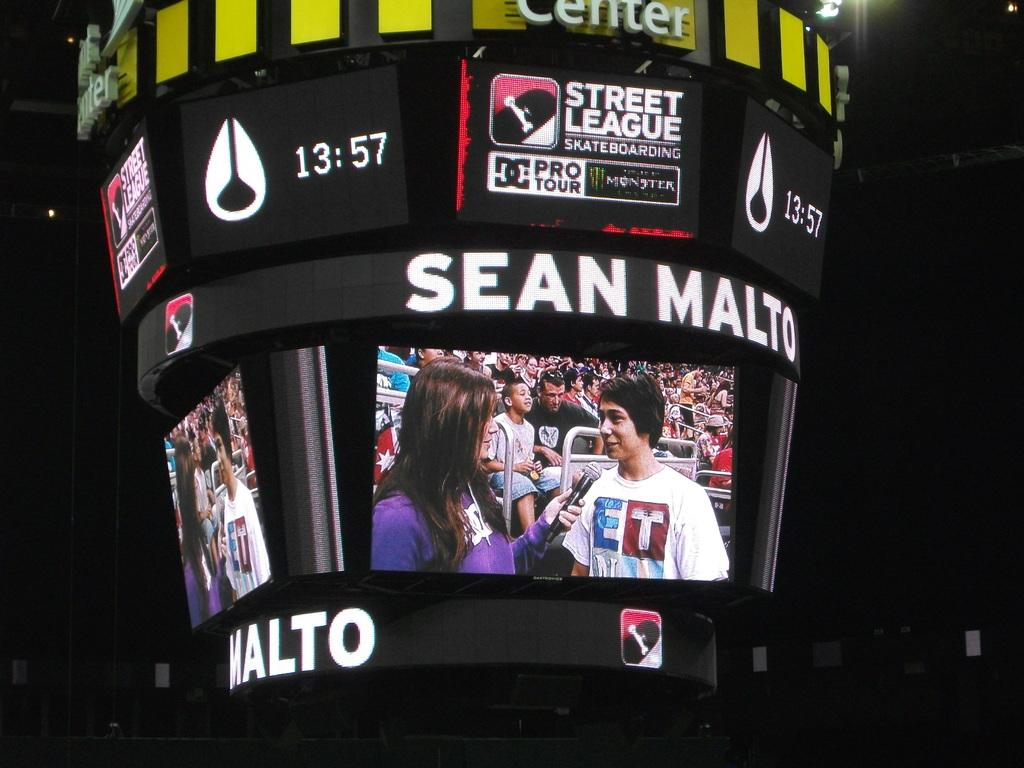<image>
Give a short and clear explanation of the subsequent image. The display monitor the Street League sports event shows a skater being interviewed. 